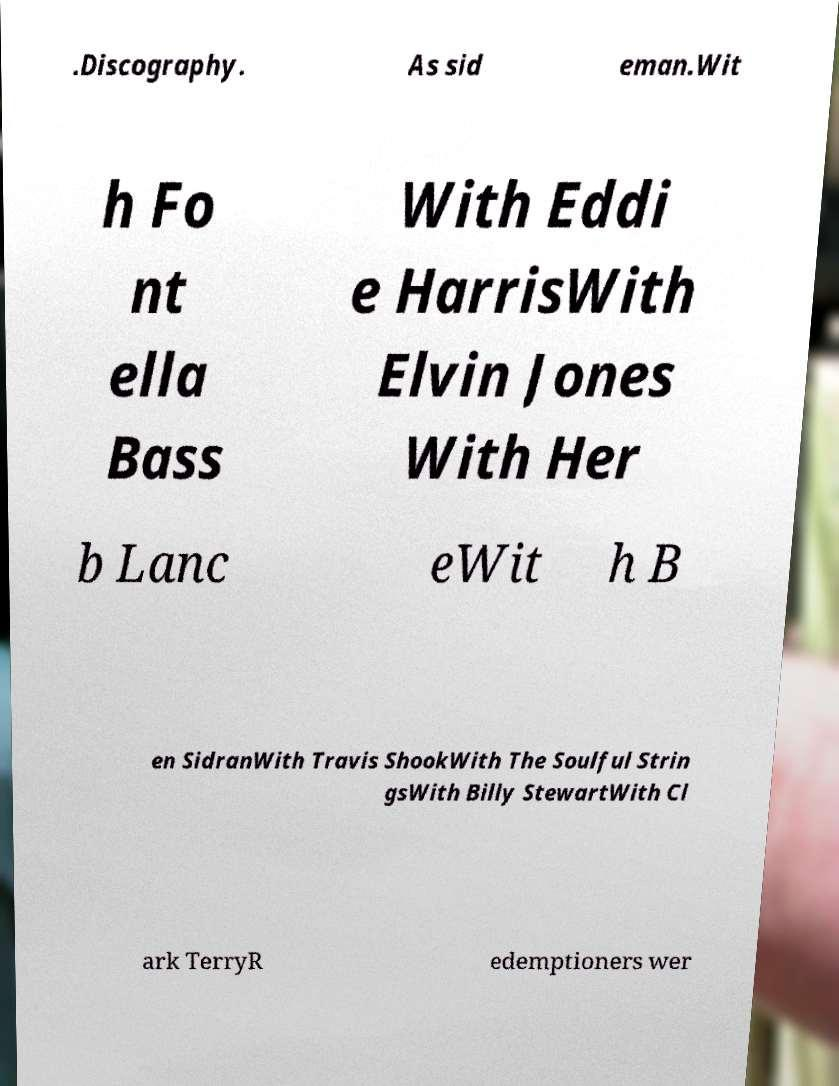I need the written content from this picture converted into text. Can you do that? .Discography. As sid eman.Wit h Fo nt ella Bass With Eddi e HarrisWith Elvin Jones With Her b Lanc eWit h B en SidranWith Travis ShookWith The Soulful Strin gsWith Billy StewartWith Cl ark TerryR edemptioners wer 